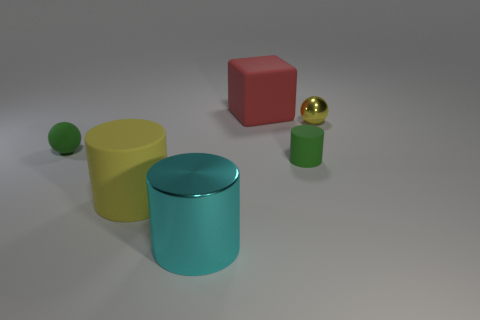How many green cylinders have the same size as the cyan shiny cylinder?
Give a very brief answer. 0. What shape is the object that is the same color as the small matte cylinder?
Give a very brief answer. Sphere. Is there a large cylinder that is behind the metal object that is to the right of the red cube?
Your response must be concise. No. How many things are either spheres in front of the tiny metal thing or tiny red matte cubes?
Your response must be concise. 1. How many tiny yellow shiny cylinders are there?
Provide a short and direct response. 0. The other big thing that is made of the same material as the large yellow thing is what shape?
Give a very brief answer. Cube. What size is the thing that is behind the tiny ball to the right of the big red object?
Provide a succinct answer. Large. How many objects are small spheres right of the red cube or yellow objects that are to the right of the big cube?
Your answer should be compact. 1. Is the number of green matte cylinders less than the number of matte objects?
Provide a succinct answer. Yes. How many things are tiny red cylinders or green things?
Make the answer very short. 2. 